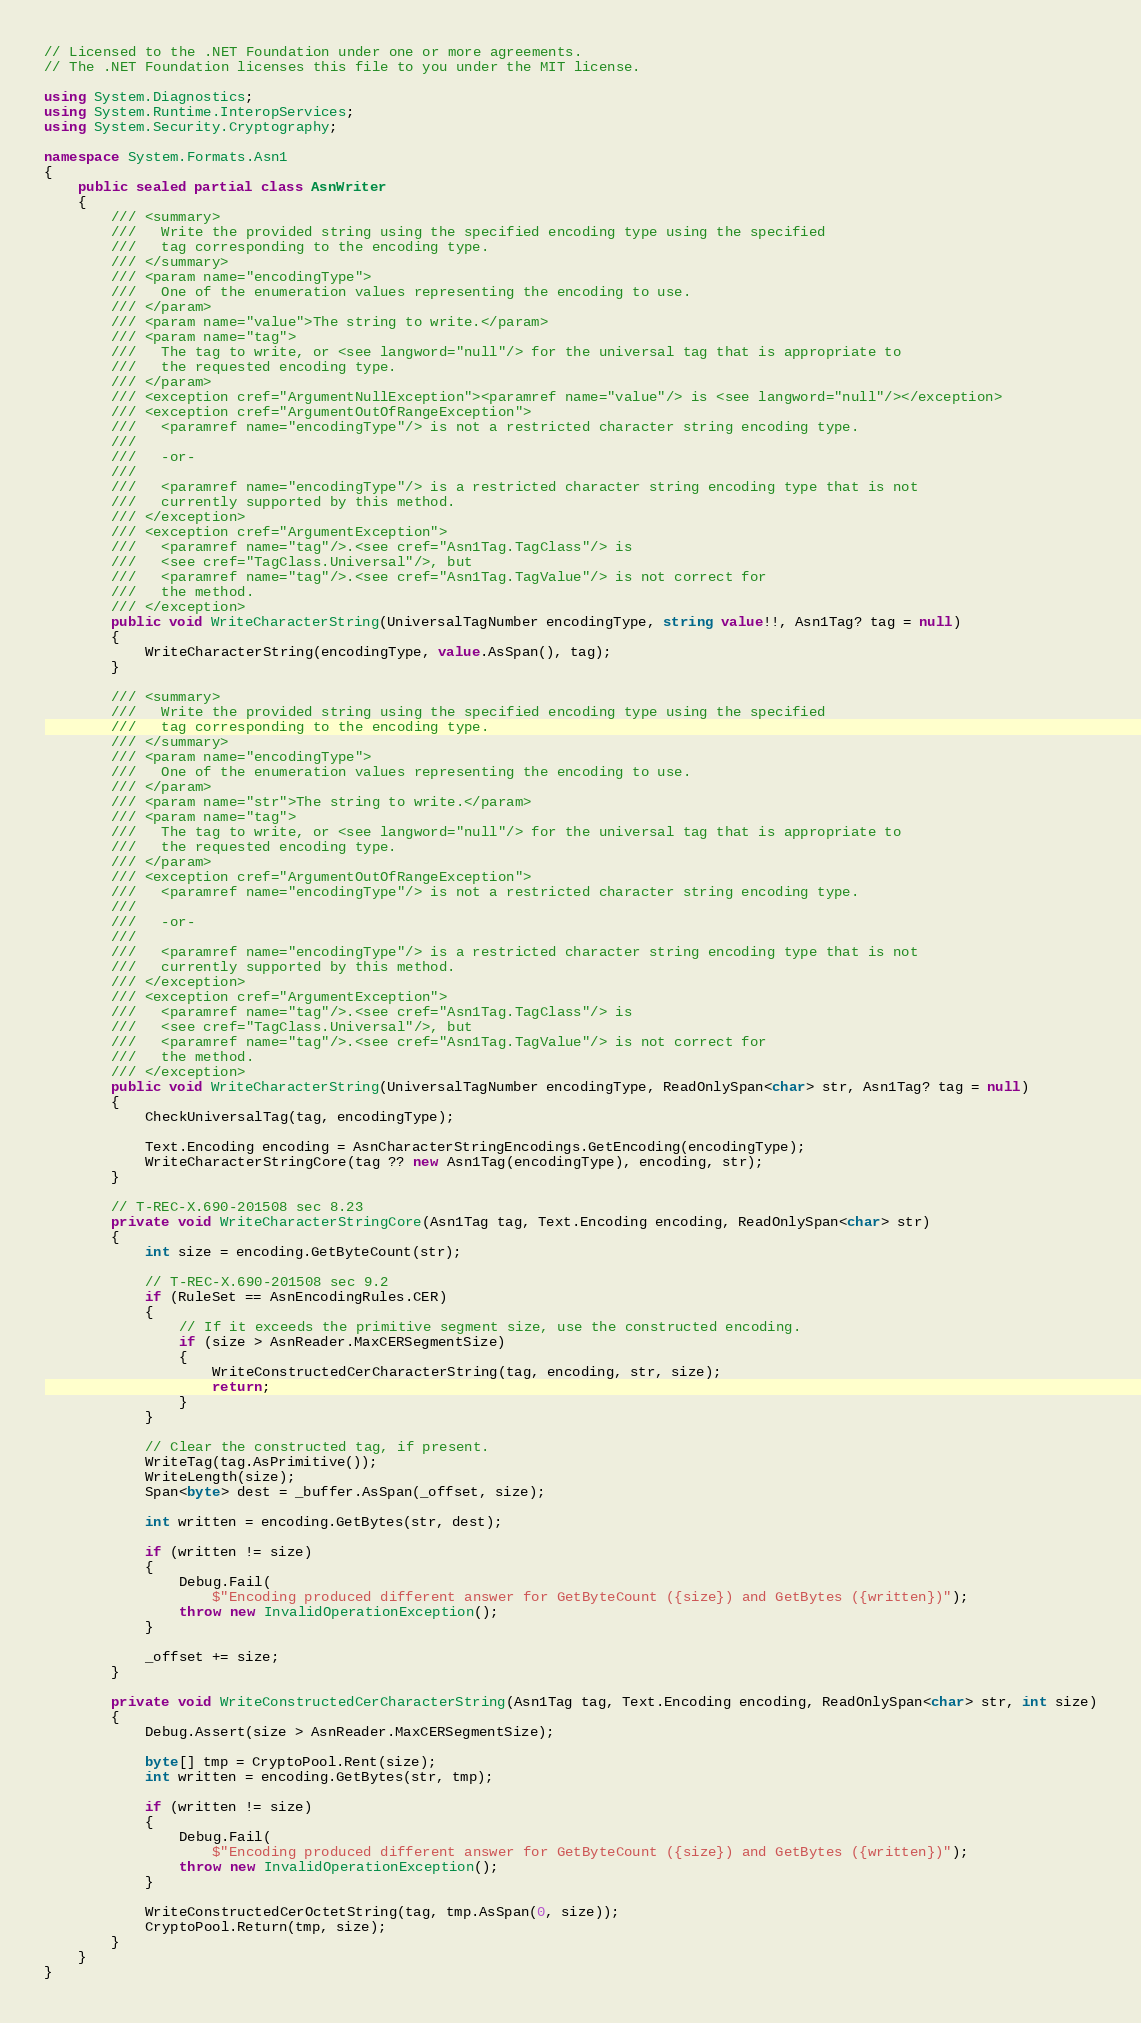<code> <loc_0><loc_0><loc_500><loc_500><_C#_>// Licensed to the .NET Foundation under one or more agreements.
// The .NET Foundation licenses this file to you under the MIT license.

using System.Diagnostics;
using System.Runtime.InteropServices;
using System.Security.Cryptography;

namespace System.Formats.Asn1
{
    public sealed partial class AsnWriter
    {
        /// <summary>
        ///   Write the provided string using the specified encoding type using the specified
        ///   tag corresponding to the encoding type.
        /// </summary>
        /// <param name="encodingType">
        ///   One of the enumeration values representing the encoding to use.
        /// </param>
        /// <param name="value">The string to write.</param>
        /// <param name="tag">
        ///   The tag to write, or <see langword="null"/> for the universal tag that is appropriate to
        ///   the requested encoding type.
        /// </param>
        /// <exception cref="ArgumentNullException"><paramref name="value"/> is <see langword="null"/></exception>
        /// <exception cref="ArgumentOutOfRangeException">
        ///   <paramref name="encodingType"/> is not a restricted character string encoding type.
        ///
        ///   -or-
        ///
        ///   <paramref name="encodingType"/> is a restricted character string encoding type that is not
        ///   currently supported by this method.
        /// </exception>
        /// <exception cref="ArgumentException">
        ///   <paramref name="tag"/>.<see cref="Asn1Tag.TagClass"/> is
        ///   <see cref="TagClass.Universal"/>, but
        ///   <paramref name="tag"/>.<see cref="Asn1Tag.TagValue"/> is not correct for
        ///   the method.
        /// </exception>
        public void WriteCharacterString(UniversalTagNumber encodingType, string value!!, Asn1Tag? tag = null)
        {
            WriteCharacterString(encodingType, value.AsSpan(), tag);
        }

        /// <summary>
        ///   Write the provided string using the specified encoding type using the specified
        ///   tag corresponding to the encoding type.
        /// </summary>
        /// <param name="encodingType">
        ///   One of the enumeration values representing the encoding to use.
        /// </param>
        /// <param name="str">The string to write.</param>
        /// <param name="tag">
        ///   The tag to write, or <see langword="null"/> for the universal tag that is appropriate to
        ///   the requested encoding type.
        /// </param>
        /// <exception cref="ArgumentOutOfRangeException">
        ///   <paramref name="encodingType"/> is not a restricted character string encoding type.
        ///
        ///   -or-
        ///
        ///   <paramref name="encodingType"/> is a restricted character string encoding type that is not
        ///   currently supported by this method.
        /// </exception>
        /// <exception cref="ArgumentException">
        ///   <paramref name="tag"/>.<see cref="Asn1Tag.TagClass"/> is
        ///   <see cref="TagClass.Universal"/>, but
        ///   <paramref name="tag"/>.<see cref="Asn1Tag.TagValue"/> is not correct for
        ///   the method.
        /// </exception>
        public void WriteCharacterString(UniversalTagNumber encodingType, ReadOnlySpan<char> str, Asn1Tag? tag = null)
        {
            CheckUniversalTag(tag, encodingType);

            Text.Encoding encoding = AsnCharacterStringEncodings.GetEncoding(encodingType);
            WriteCharacterStringCore(tag ?? new Asn1Tag(encodingType), encoding, str);
        }

        // T-REC-X.690-201508 sec 8.23
        private void WriteCharacterStringCore(Asn1Tag tag, Text.Encoding encoding, ReadOnlySpan<char> str)
        {
            int size = encoding.GetByteCount(str);

            // T-REC-X.690-201508 sec 9.2
            if (RuleSet == AsnEncodingRules.CER)
            {
                // If it exceeds the primitive segment size, use the constructed encoding.
                if (size > AsnReader.MaxCERSegmentSize)
                {
                    WriteConstructedCerCharacterString(tag, encoding, str, size);
                    return;
                }
            }

            // Clear the constructed tag, if present.
            WriteTag(tag.AsPrimitive());
            WriteLength(size);
            Span<byte> dest = _buffer.AsSpan(_offset, size);

            int written = encoding.GetBytes(str, dest);

            if (written != size)
            {
                Debug.Fail(
                    $"Encoding produced different answer for GetByteCount ({size}) and GetBytes ({written})");
                throw new InvalidOperationException();
            }

            _offset += size;
        }

        private void WriteConstructedCerCharacterString(Asn1Tag tag, Text.Encoding encoding, ReadOnlySpan<char> str, int size)
        {
            Debug.Assert(size > AsnReader.MaxCERSegmentSize);

            byte[] tmp = CryptoPool.Rent(size);
            int written = encoding.GetBytes(str, tmp);

            if (written != size)
            {
                Debug.Fail(
                    $"Encoding produced different answer for GetByteCount ({size}) and GetBytes ({written})");
                throw new InvalidOperationException();
            }

            WriteConstructedCerOctetString(tag, tmp.AsSpan(0, size));
            CryptoPool.Return(tmp, size);
        }
    }
}
</code> 